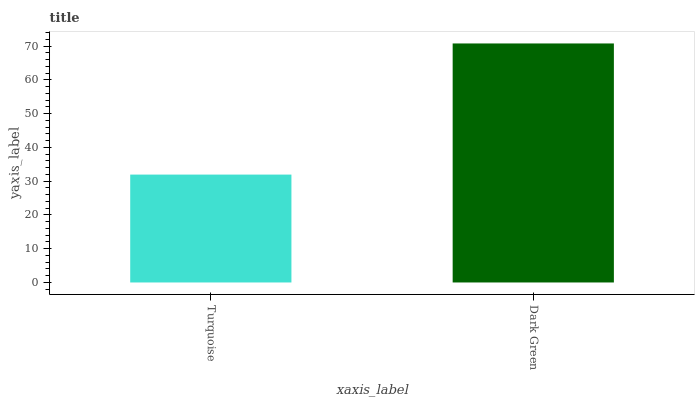Is Turquoise the minimum?
Answer yes or no. Yes. Is Dark Green the maximum?
Answer yes or no. Yes. Is Dark Green the minimum?
Answer yes or no. No. Is Dark Green greater than Turquoise?
Answer yes or no. Yes. Is Turquoise less than Dark Green?
Answer yes or no. Yes. Is Turquoise greater than Dark Green?
Answer yes or no. No. Is Dark Green less than Turquoise?
Answer yes or no. No. Is Dark Green the high median?
Answer yes or no. Yes. Is Turquoise the low median?
Answer yes or no. Yes. Is Turquoise the high median?
Answer yes or no. No. Is Dark Green the low median?
Answer yes or no. No. 